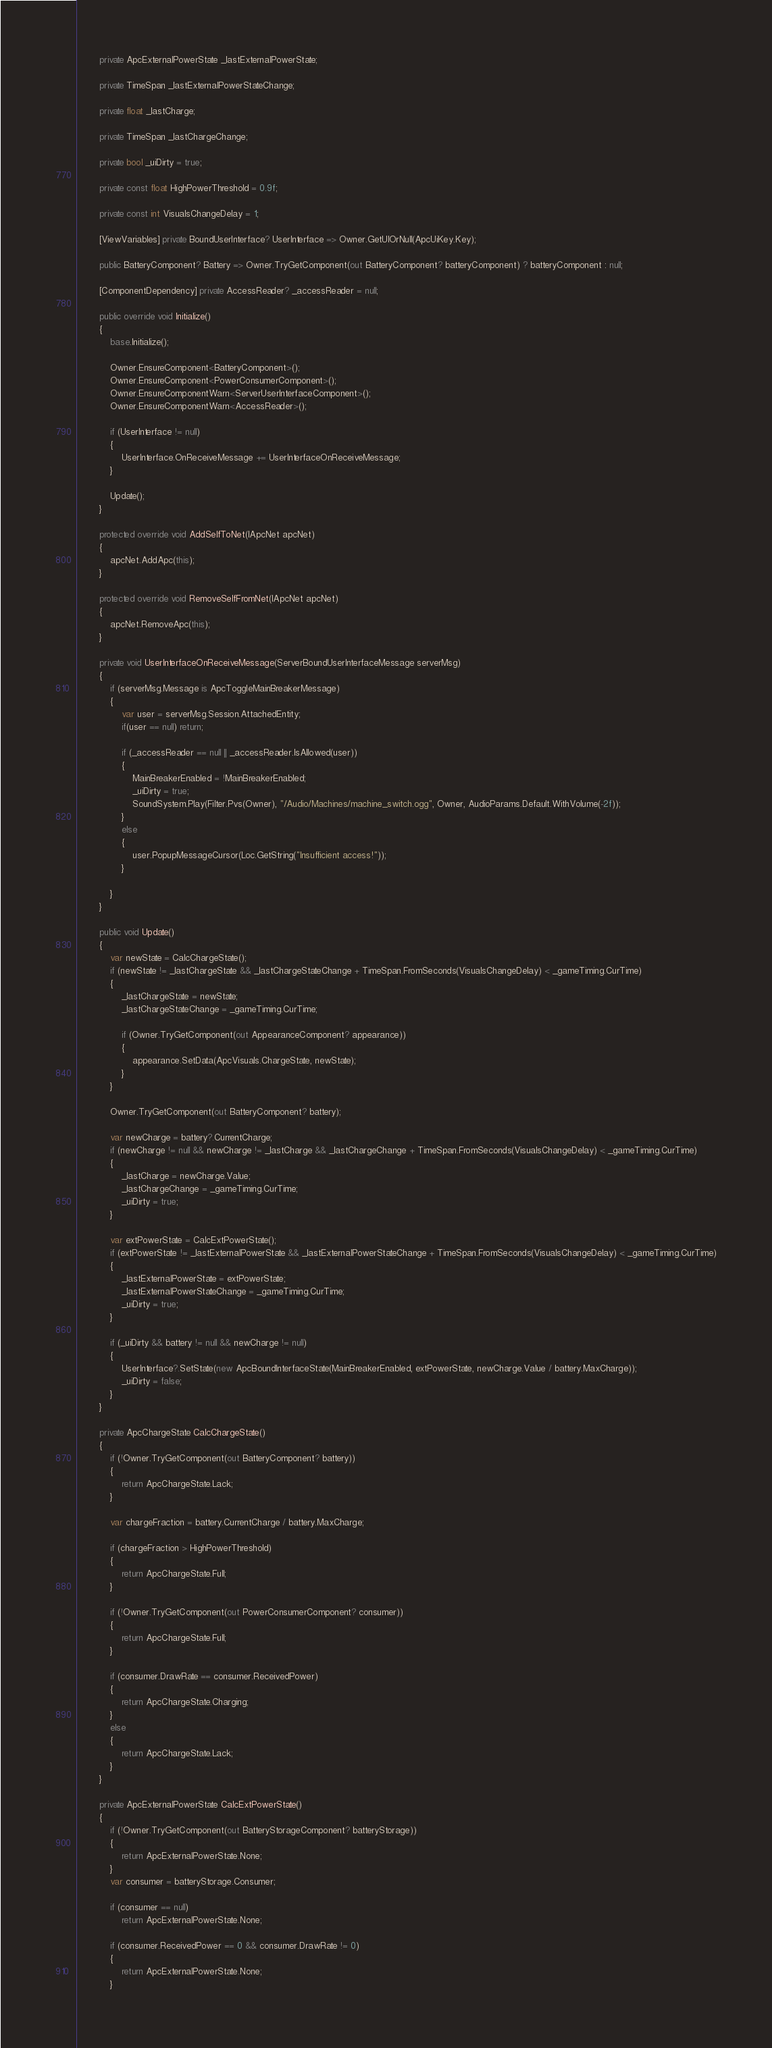<code> <loc_0><loc_0><loc_500><loc_500><_C#_>        private ApcExternalPowerState _lastExternalPowerState;

        private TimeSpan _lastExternalPowerStateChange;

        private float _lastCharge;

        private TimeSpan _lastChargeChange;

        private bool _uiDirty = true;

        private const float HighPowerThreshold = 0.9f;

        private const int VisualsChangeDelay = 1;

        [ViewVariables] private BoundUserInterface? UserInterface => Owner.GetUIOrNull(ApcUiKey.Key);

        public BatteryComponent? Battery => Owner.TryGetComponent(out BatteryComponent? batteryComponent) ? batteryComponent : null;

        [ComponentDependency] private AccessReader? _accessReader = null;

        public override void Initialize()
        {
            base.Initialize();

            Owner.EnsureComponent<BatteryComponent>();
            Owner.EnsureComponent<PowerConsumerComponent>();
            Owner.EnsureComponentWarn<ServerUserInterfaceComponent>();
            Owner.EnsureComponentWarn<AccessReader>();

            if (UserInterface != null)
            {
                UserInterface.OnReceiveMessage += UserInterfaceOnReceiveMessage;
            }

            Update();
        }

        protected override void AddSelfToNet(IApcNet apcNet)
        {
            apcNet.AddApc(this);
        }

        protected override void RemoveSelfFromNet(IApcNet apcNet)
        {
            apcNet.RemoveApc(this);
        }

        private void UserInterfaceOnReceiveMessage(ServerBoundUserInterfaceMessage serverMsg)
        {
            if (serverMsg.Message is ApcToggleMainBreakerMessage)
            {
                var user = serverMsg.Session.AttachedEntity;
                if(user == null) return;

                if (_accessReader == null || _accessReader.IsAllowed(user))
                {
                    MainBreakerEnabled = !MainBreakerEnabled;
                    _uiDirty = true;
                    SoundSystem.Play(Filter.Pvs(Owner), "/Audio/Machines/machine_switch.ogg", Owner, AudioParams.Default.WithVolume(-2f));
                }
                else
                {
                    user.PopupMessageCursor(Loc.GetString("Insufficient access!"));
                }

            }
        }

        public void Update()
        {
            var newState = CalcChargeState();
            if (newState != _lastChargeState && _lastChargeStateChange + TimeSpan.FromSeconds(VisualsChangeDelay) < _gameTiming.CurTime)
            {
                _lastChargeState = newState;
                _lastChargeStateChange = _gameTiming.CurTime;

                if (Owner.TryGetComponent(out AppearanceComponent? appearance))
                {
                    appearance.SetData(ApcVisuals.ChargeState, newState);
                }
            }

            Owner.TryGetComponent(out BatteryComponent? battery);

            var newCharge = battery?.CurrentCharge;
            if (newCharge != null && newCharge != _lastCharge && _lastChargeChange + TimeSpan.FromSeconds(VisualsChangeDelay) < _gameTiming.CurTime)
            {
                _lastCharge = newCharge.Value;
                _lastChargeChange = _gameTiming.CurTime;
                _uiDirty = true;
            }

            var extPowerState = CalcExtPowerState();
            if (extPowerState != _lastExternalPowerState && _lastExternalPowerStateChange + TimeSpan.FromSeconds(VisualsChangeDelay) < _gameTiming.CurTime)
            {
                _lastExternalPowerState = extPowerState;
                _lastExternalPowerStateChange = _gameTiming.CurTime;
                _uiDirty = true;
            }

            if (_uiDirty && battery != null && newCharge != null)
            {
                UserInterface?.SetState(new ApcBoundInterfaceState(MainBreakerEnabled, extPowerState, newCharge.Value / battery.MaxCharge));
                _uiDirty = false;
            }
        }

        private ApcChargeState CalcChargeState()
        {
            if (!Owner.TryGetComponent(out BatteryComponent? battery))
            {
                return ApcChargeState.Lack;
            }

            var chargeFraction = battery.CurrentCharge / battery.MaxCharge;

            if (chargeFraction > HighPowerThreshold)
            {
                return ApcChargeState.Full;
            }

            if (!Owner.TryGetComponent(out PowerConsumerComponent? consumer))
            {
                return ApcChargeState.Full;
            }

            if (consumer.DrawRate == consumer.ReceivedPower)
            {
                return ApcChargeState.Charging;
            }
            else
            {
                return ApcChargeState.Lack;
            }
        }

        private ApcExternalPowerState CalcExtPowerState()
        {
            if (!Owner.TryGetComponent(out BatteryStorageComponent? batteryStorage))
            {
                return ApcExternalPowerState.None;
            }
            var consumer = batteryStorage.Consumer;

            if (consumer == null)
                return ApcExternalPowerState.None;

            if (consumer.ReceivedPower == 0 && consumer.DrawRate != 0)
            {
                return ApcExternalPowerState.None;
            }</code> 